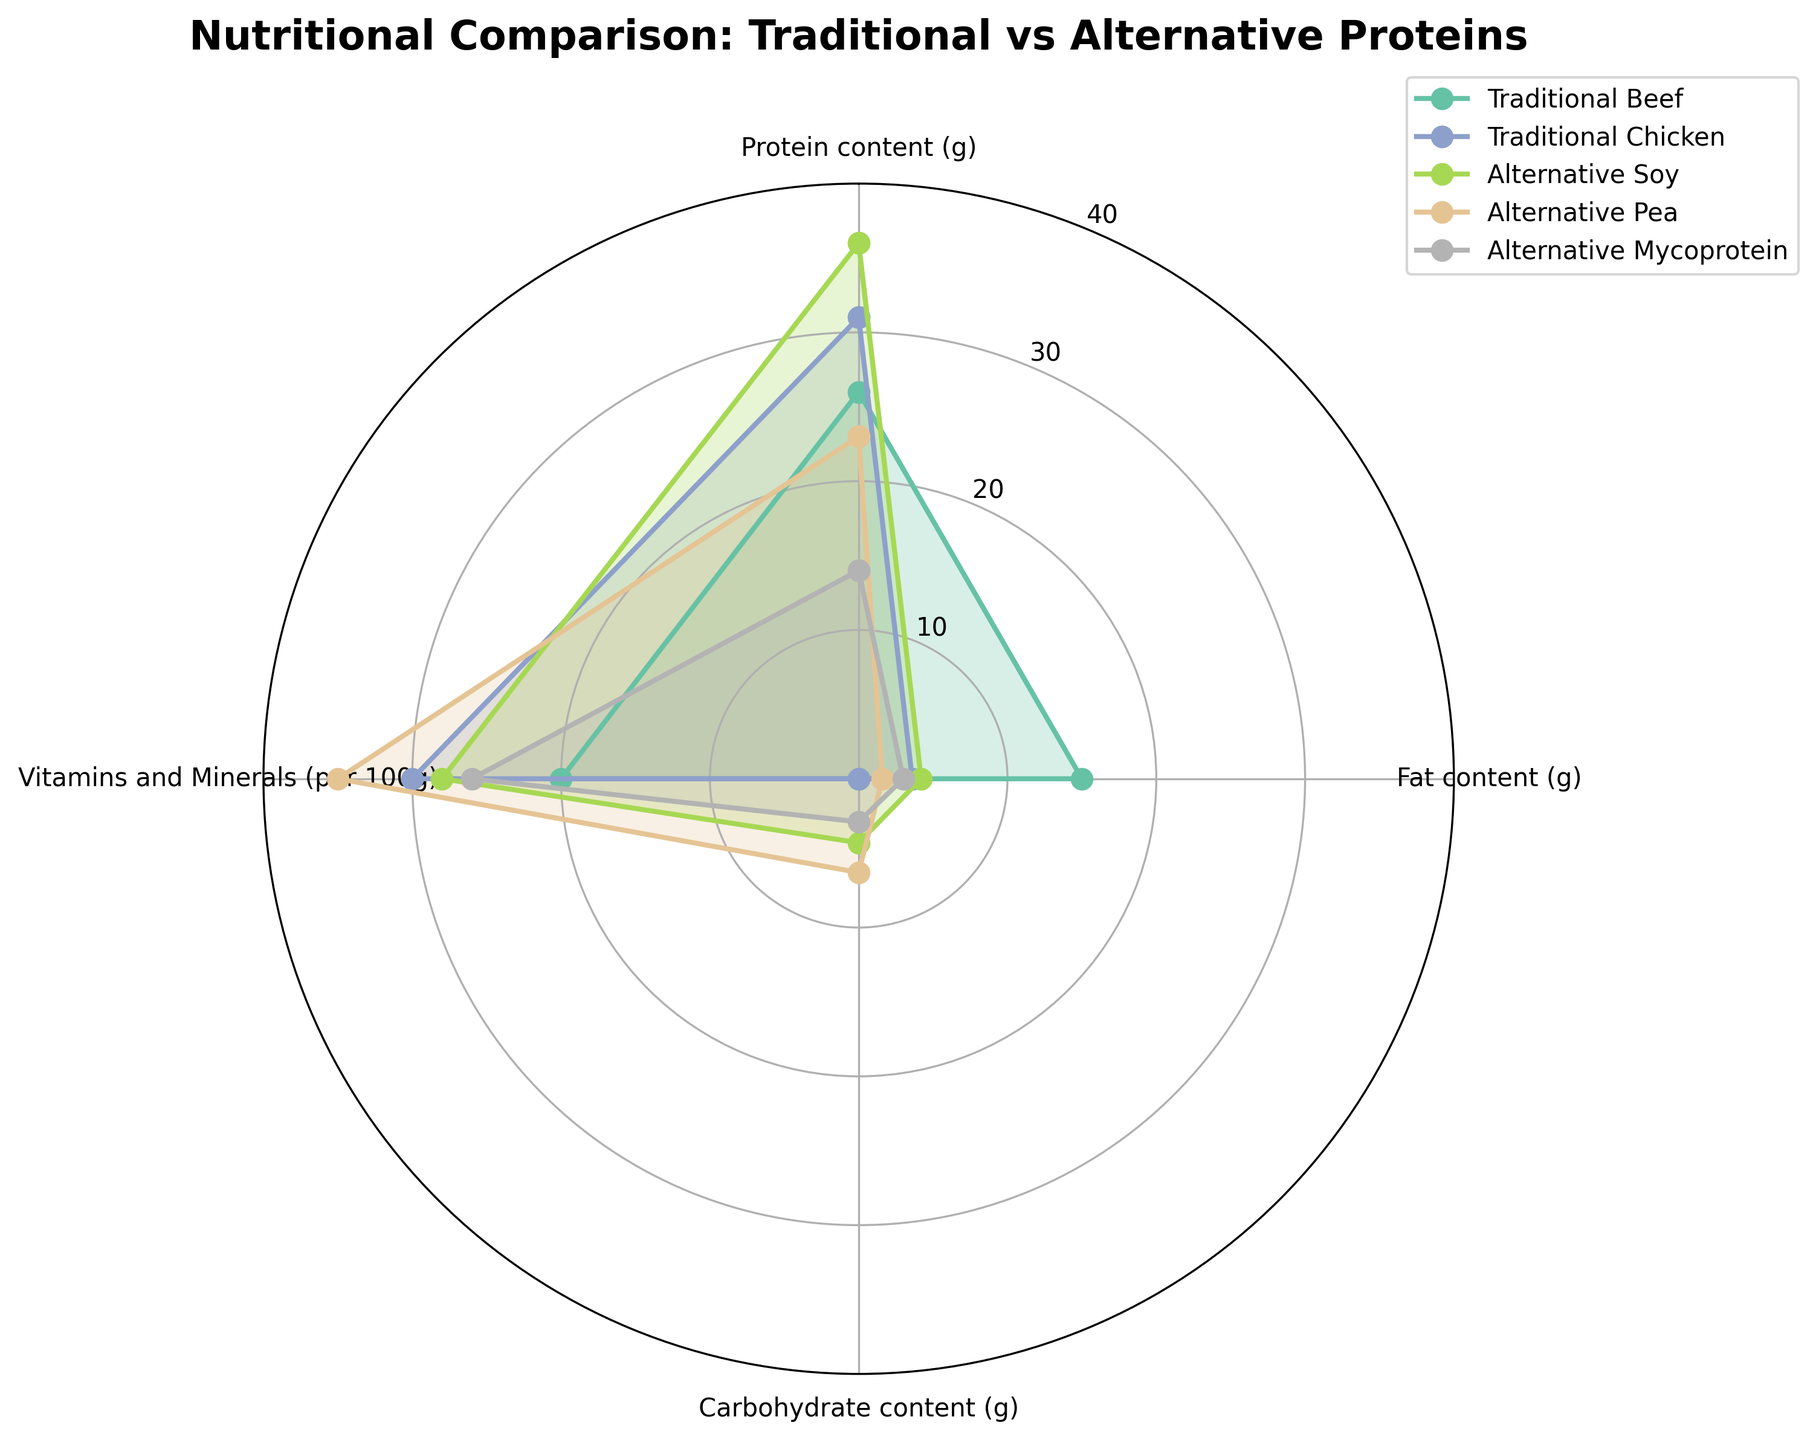What's the title of the chart? The title of the chart is usually located at the top. Here, it reads "Nutritional Comparison: Traditional vs Alternative Proteins".
Answer: Nutritional Comparison: Traditional vs Alternative Proteins Which category has the highest value for protein content? To find this, look at the 'Protein content (g)' values. The highest value is 36g for 'Alternative Soy'.
Answer: Alternative Soy How many categories are compared in the chart? The position and labels of the angular grid lines (the gridlines starting from the center and going outwards) help us identify how many categories there are. In this chart, there are four radial lines: Protein content, Fat content, Carbohydrate content, and Vitamins and Minerals.
Answer: 4 Which protein type has the lowest fat content? Look at the 'Fat content (g)' values. The lowest value is 1.6g for 'Alternative Pea'.
Answer: Alternative Pea Comparing Traditional Beef and Alternative Mycoprotein, which has a higher carbohydrate content? Find the 'Carbohydrate content (g)' values for both: Traditional Beef has 0g while Alternative Mycoprotein has 2.9g. Therefore, Alternative Mycoprotein has a higher carbohydrate content.
Answer: Alternative Mycoprotein What is the difference in vitamin and mineral content between Traditional Chicken and Alternative Pea? Look at the 'Vitamins and Minerals (per 100g)' values for both: Traditional Chicken has 30 and Alternative Pea has 35. The difference is 35 - 30 = 5.
Answer: 5 Which protein type has the closest balance of protein, fat, carb, and vitamins & minerals values? In a radial chart, balance can be visualized by observing which plot appears most circular. Alternative Mycoprotein seems most balanced, as its values are relatively even across categories compared to the others.
Answer: Alternative Mycoprotein Is there any protein type that has zero carbohydrate content? Look for the 'Carbohydrate content (g)' values. Both Traditional Beef and Traditional Chicken have 0g carbohydrate content.
Answer: Traditional Beef, Traditional Chicken 